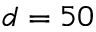Convert formula to latex. <formula><loc_0><loc_0><loc_500><loc_500>d = 5 0</formula> 